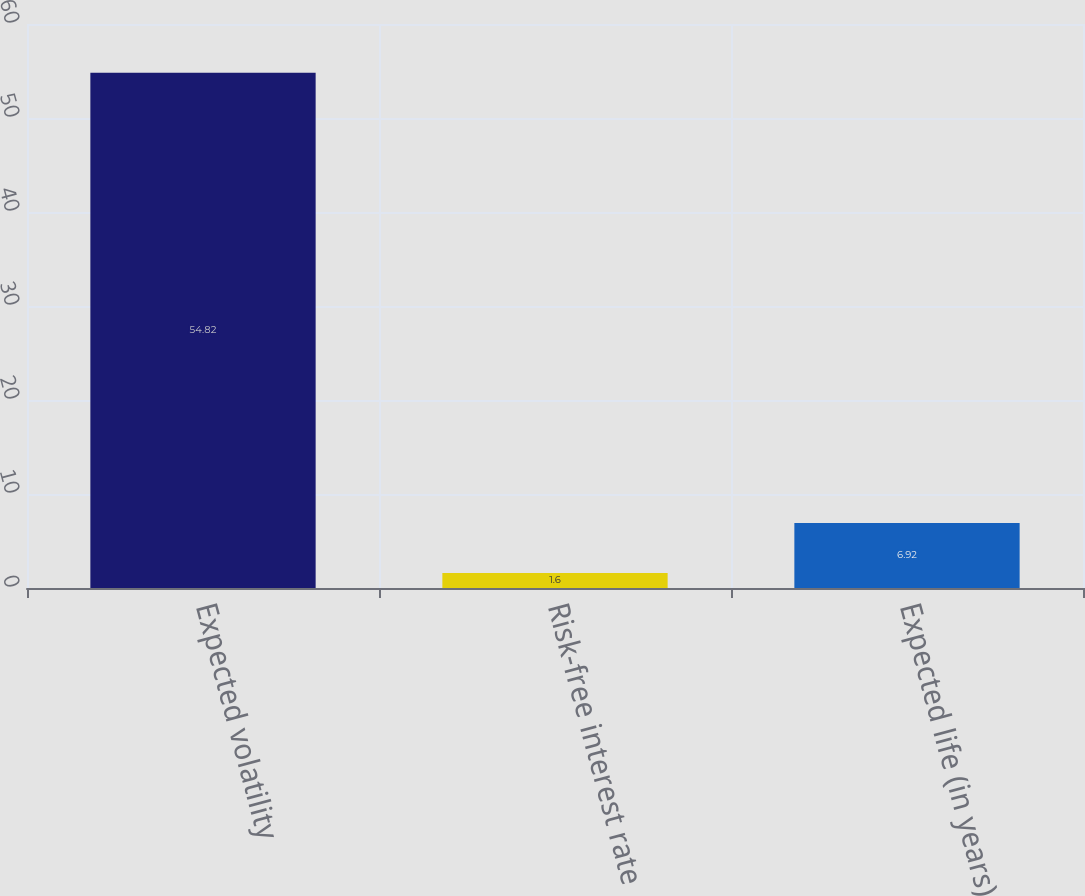<chart> <loc_0><loc_0><loc_500><loc_500><bar_chart><fcel>Expected volatility<fcel>Risk-free interest rate<fcel>Expected life (in years)<nl><fcel>54.82<fcel>1.6<fcel>6.92<nl></chart> 